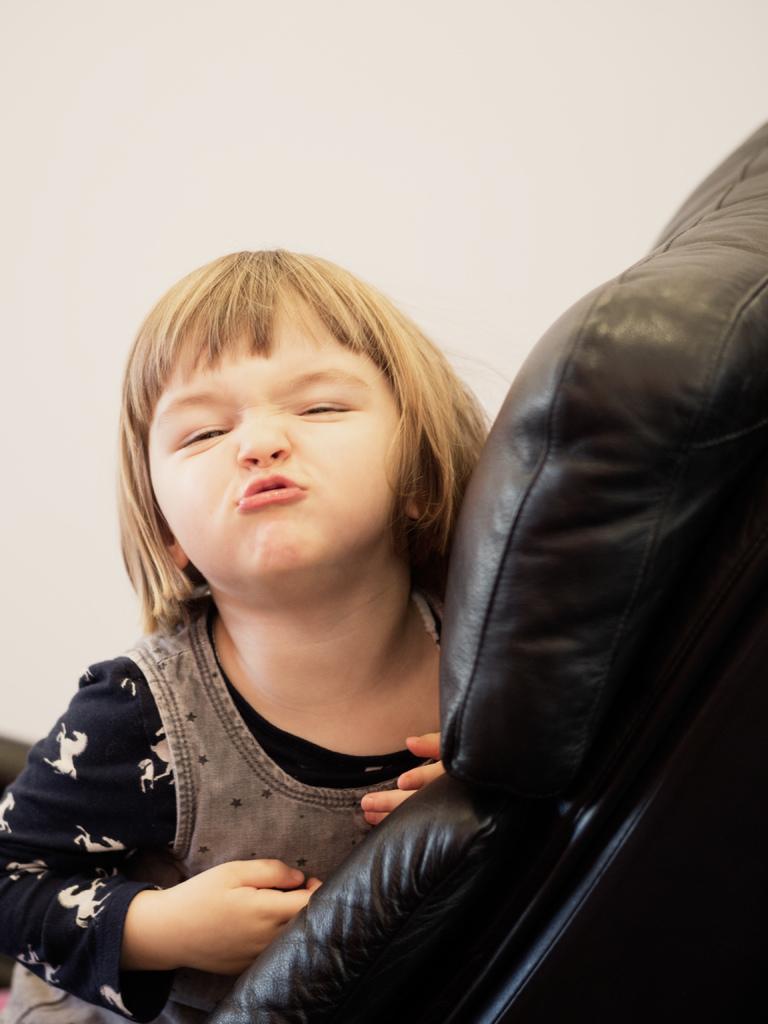How would you summarize this image in a sentence or two? In the foreground of this picture, there is a girl with a funky expression on her face sitting on a black chair. In the background, there is a wall. 